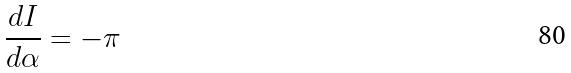Convert formula to latex. <formula><loc_0><loc_0><loc_500><loc_500>\frac { d I } { d \alpha } = - \pi</formula> 